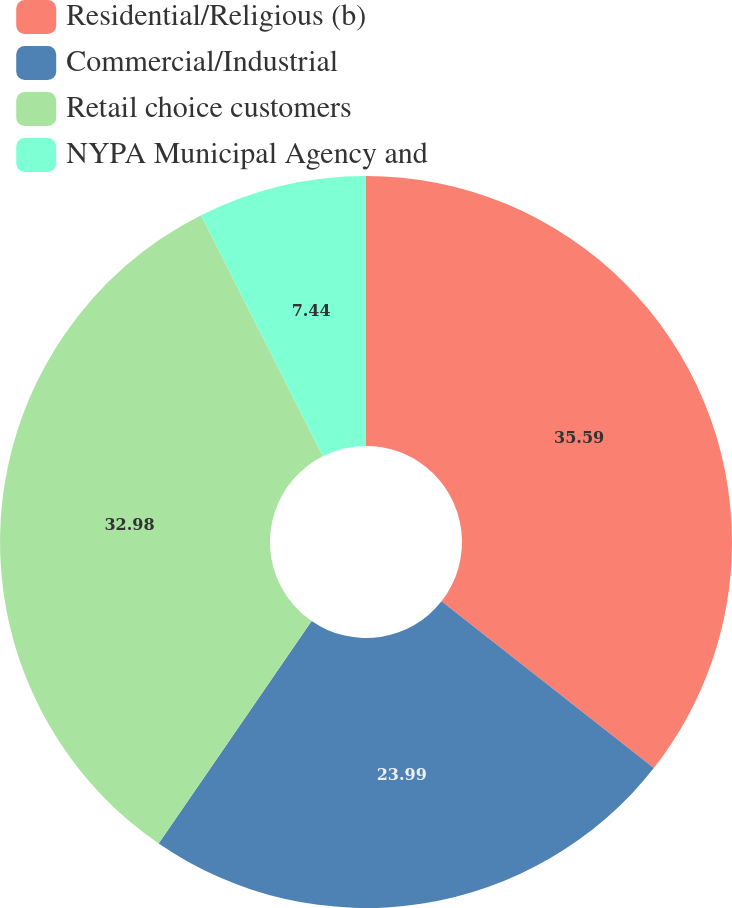Convert chart. <chart><loc_0><loc_0><loc_500><loc_500><pie_chart><fcel>Residential/Religious (b)<fcel>Commercial/Industrial<fcel>Retail choice customers<fcel>NYPA Municipal Agency and<nl><fcel>35.6%<fcel>23.99%<fcel>32.98%<fcel>7.44%<nl></chart> 